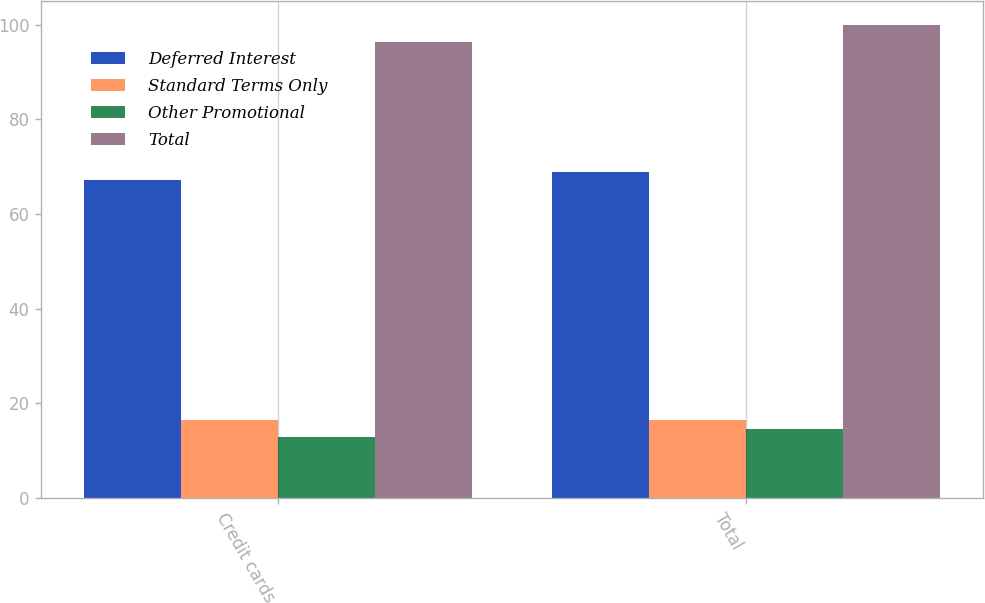Convert chart to OTSL. <chart><loc_0><loc_0><loc_500><loc_500><stacked_bar_chart><ecel><fcel>Credit cards<fcel>Total<nl><fcel>Deferred Interest<fcel>67.1<fcel>68.9<nl><fcel>Standard Terms Only<fcel>16.5<fcel>16.5<nl><fcel>Other Promotional<fcel>12.8<fcel>14.6<nl><fcel>Total<fcel>96.4<fcel>100<nl></chart> 